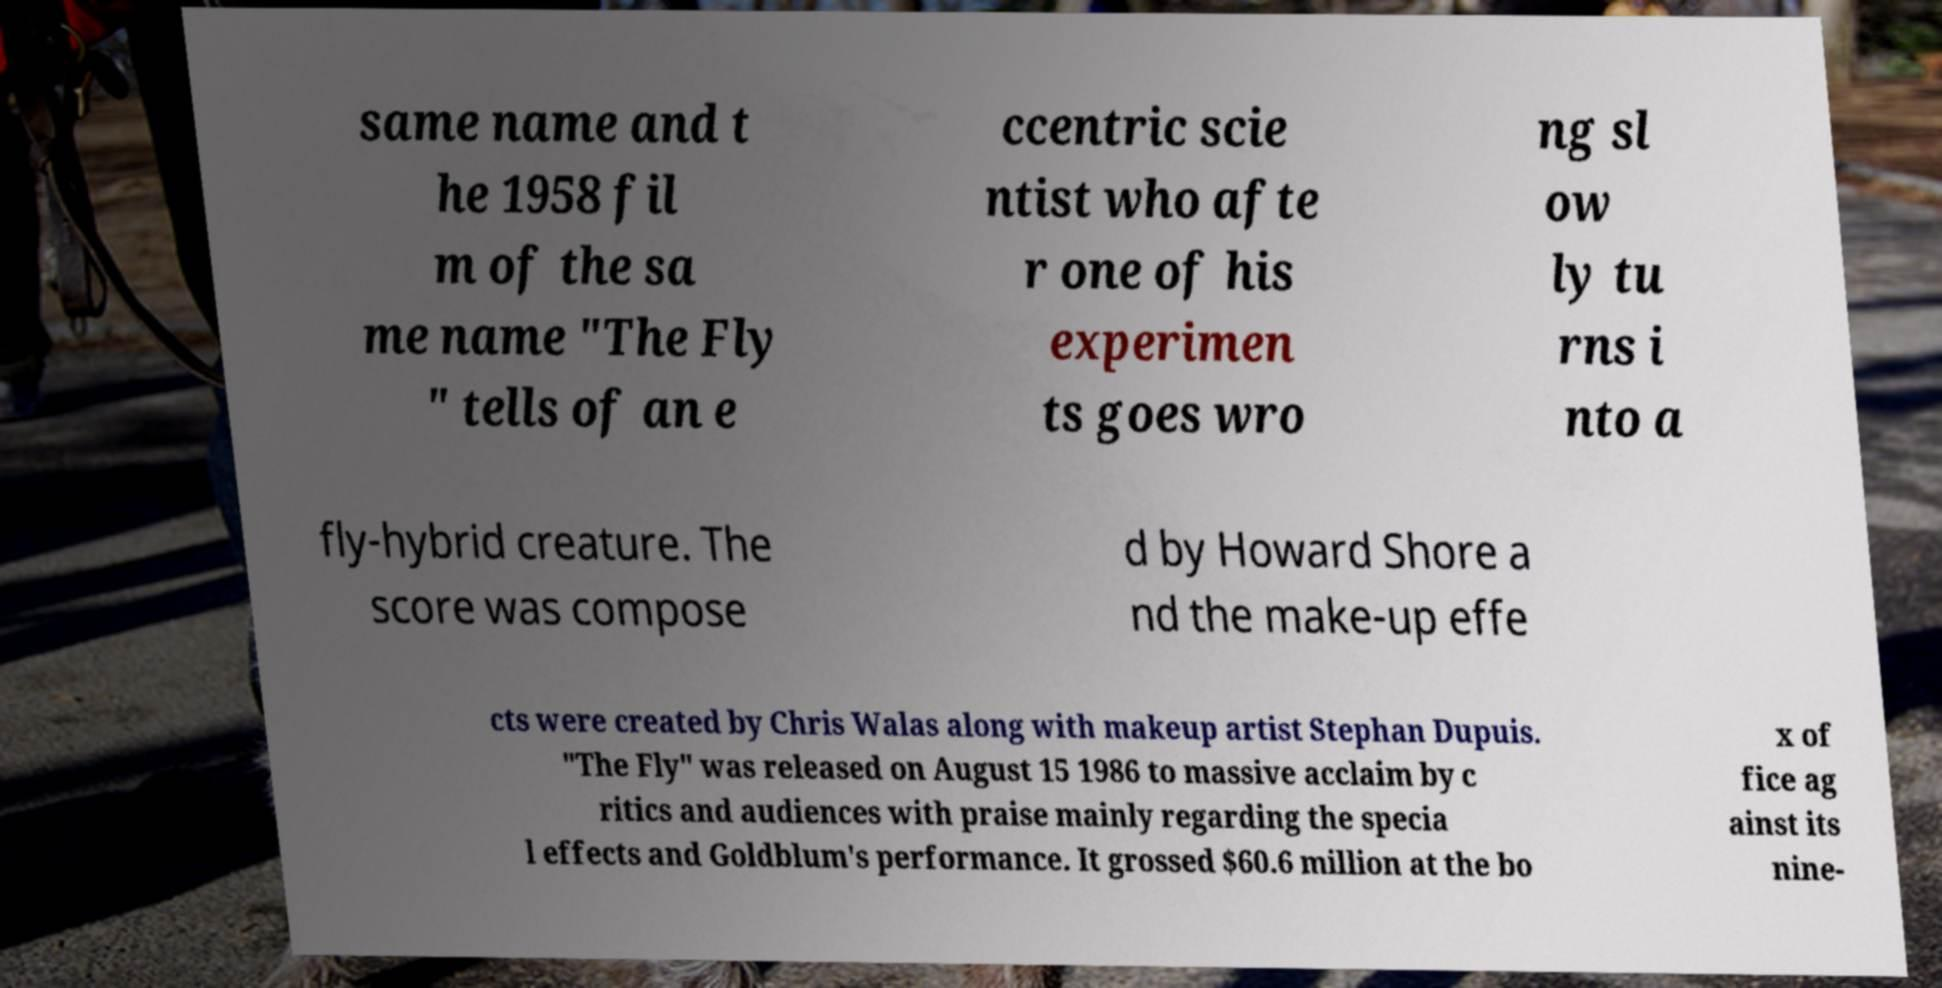There's text embedded in this image that I need extracted. Can you transcribe it verbatim? same name and t he 1958 fil m of the sa me name "The Fly " tells of an e ccentric scie ntist who afte r one of his experimen ts goes wro ng sl ow ly tu rns i nto a fly-hybrid creature. The score was compose d by Howard Shore a nd the make-up effe cts were created by Chris Walas along with makeup artist Stephan Dupuis. "The Fly" was released on August 15 1986 to massive acclaim by c ritics and audiences with praise mainly regarding the specia l effects and Goldblum's performance. It grossed $60.6 million at the bo x of fice ag ainst its nine- 